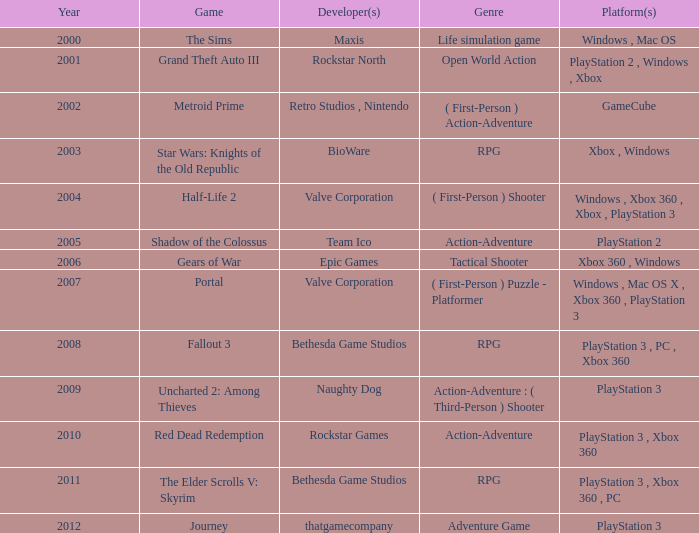In 2001, what game was introduced? Grand Theft Auto III. 